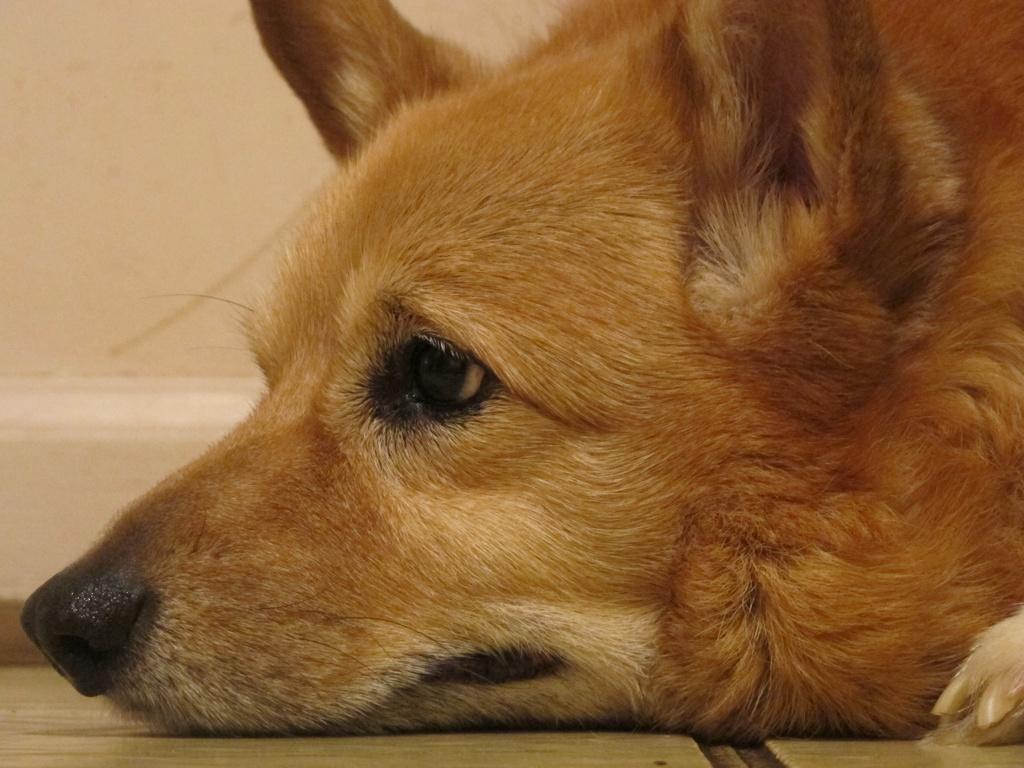In one or two sentences, can you explain what this image depicts? In front of the image there is a dog lying on the floor. Behind the dog there is a wall. 